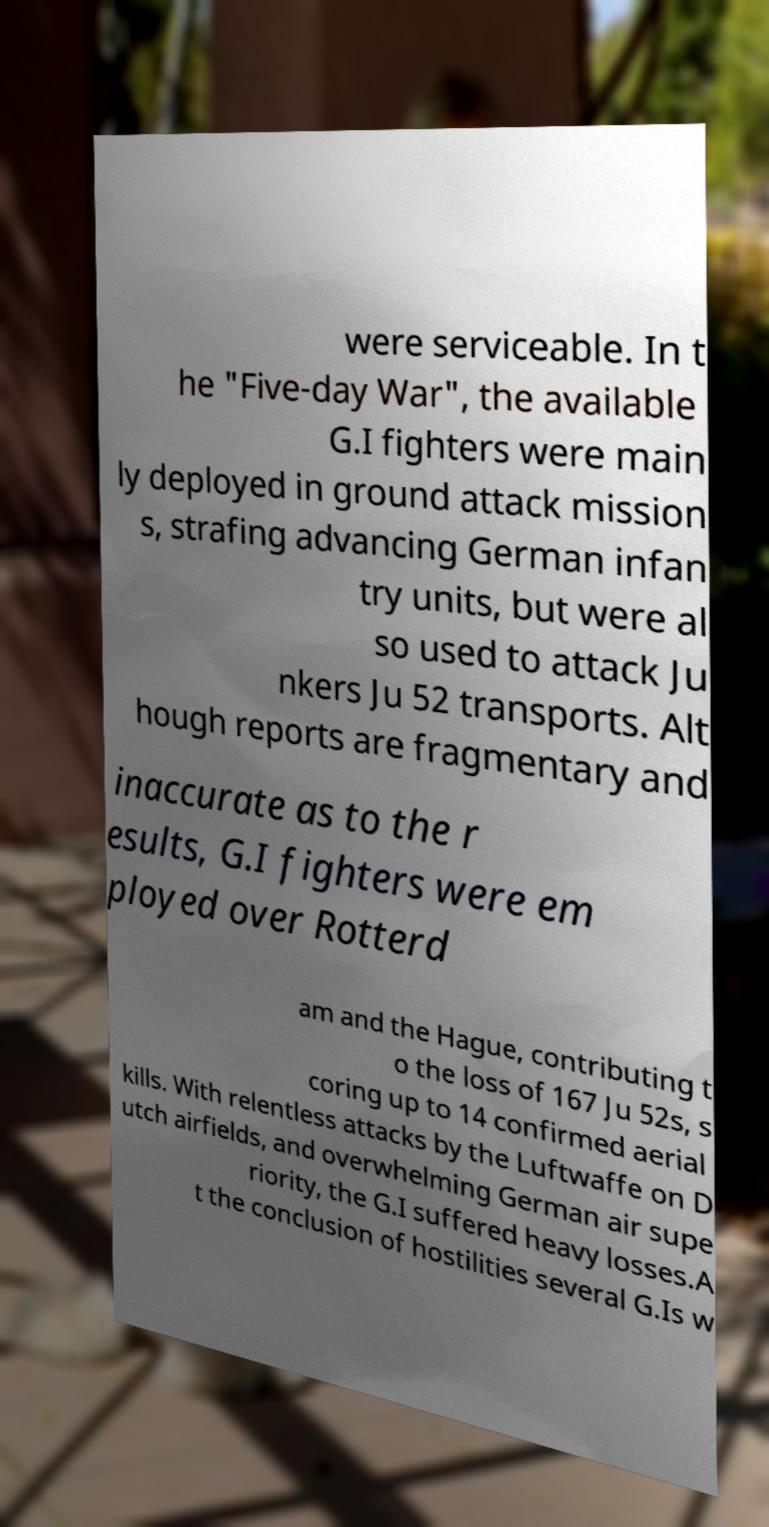I need the written content from this picture converted into text. Can you do that? were serviceable. In t he "Five-day War", the available G.I fighters were main ly deployed in ground attack mission s, strafing advancing German infan try units, but were al so used to attack Ju nkers Ju 52 transports. Alt hough reports are fragmentary and inaccurate as to the r esults, G.I fighters were em ployed over Rotterd am and the Hague, contributing t o the loss of 167 Ju 52s, s coring up to 14 confirmed aerial kills. With relentless attacks by the Luftwaffe on D utch airfields, and overwhelming German air supe riority, the G.I suffered heavy losses.A t the conclusion of hostilities several G.Is w 